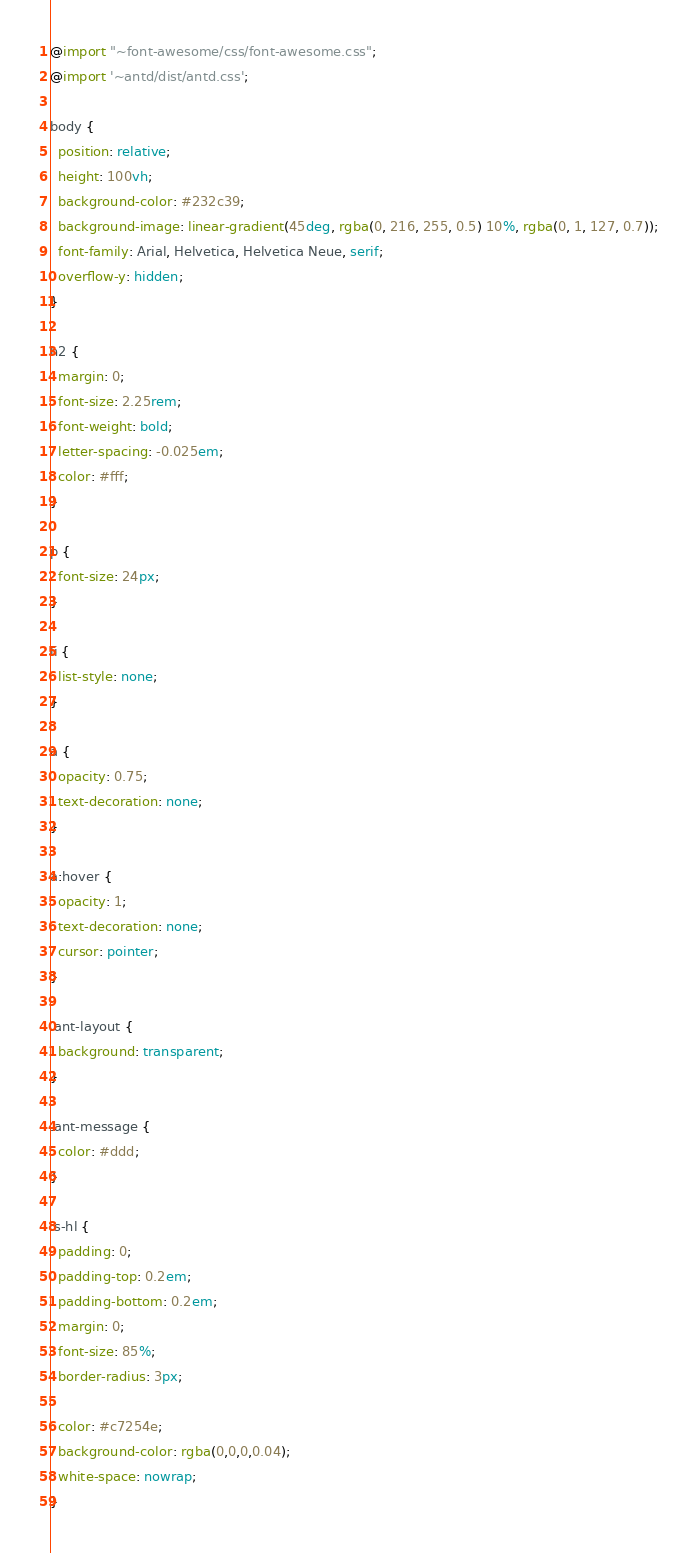Convert code to text. <code><loc_0><loc_0><loc_500><loc_500><_CSS_>@import "~font-awesome/css/font-awesome.css";
@import '~antd/dist/antd.css';

body {
  position: relative;
  height: 100vh;
  background-color: #232c39;
  background-image: linear-gradient(45deg, rgba(0, 216, 255, 0.5) 10%, rgba(0, 1, 127, 0.7));
  font-family: Arial, Helvetica, Helvetica Neue, serif;
  overflow-y: hidden;
}

h2 {
  margin: 0;
  font-size: 2.25rem;
  font-weight: bold;
  letter-spacing: -0.025em;
  color: #fff;
}

p {
  font-size: 24px;
}

li {
  list-style: none;
}

a {
  opacity: 0.75;
  text-decoration: none;
}

a:hover {
  opacity: 1;
  text-decoration: none;
  cursor: pointer;
}

.ant-layout {
  background: transparent;
}

.ant-message {
  color: #ddd;
}

.s-hl {
  padding: 0;
  padding-top: 0.2em;
  padding-bottom: 0.2em;
  margin: 0;
  font-size: 85%;
  border-radius: 3px;

  color: #c7254e;
  background-color: rgba(0,0,0,0.04);
  white-space: nowrap;
}
</code> 